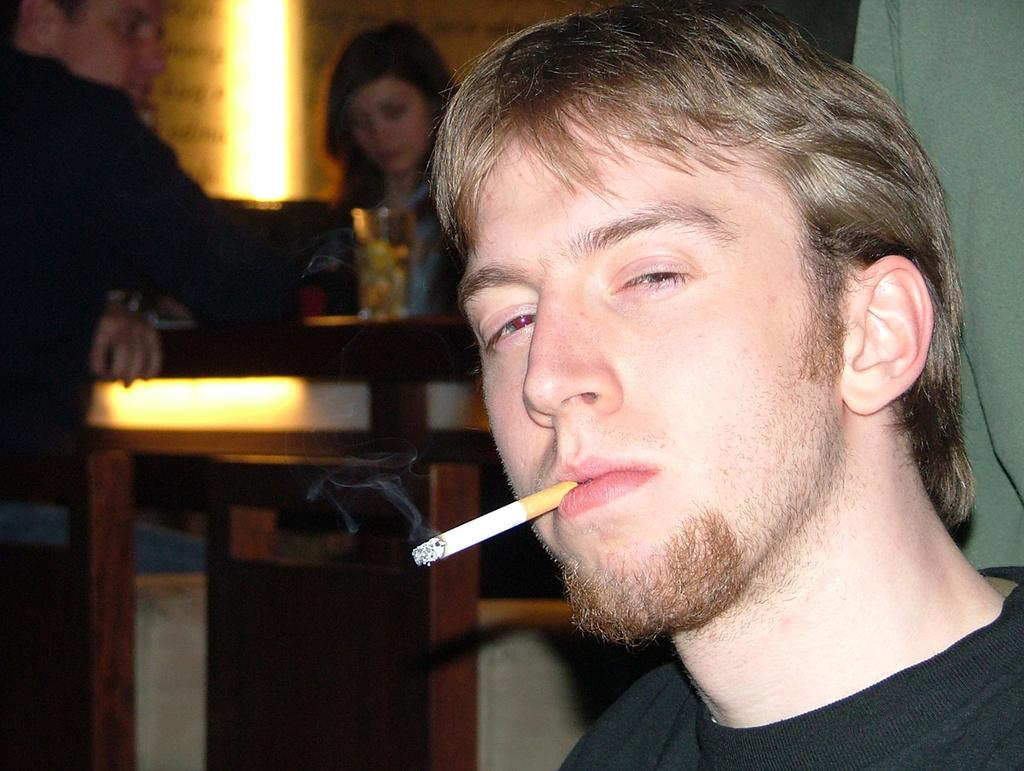What can be seen on the right side of the image? There is a person on the right side of the image. What is the person wearing? The person is wearing a black t-shirt. What activity is the person engaged in? The person is smoking a cigarette. What is happening in the background of the image? There are people sitting around a table in the background. What objects are on the table? There are wine glasses on the table. Where is the jar of pickles located in the image? There is no jar of pickles present in the image. What type of snake can be seen slithering across the table in the image? There is no snake present in the image; it only features a person, a black t-shirt, a cigarette, people sitting around a table, and wine glasses. 